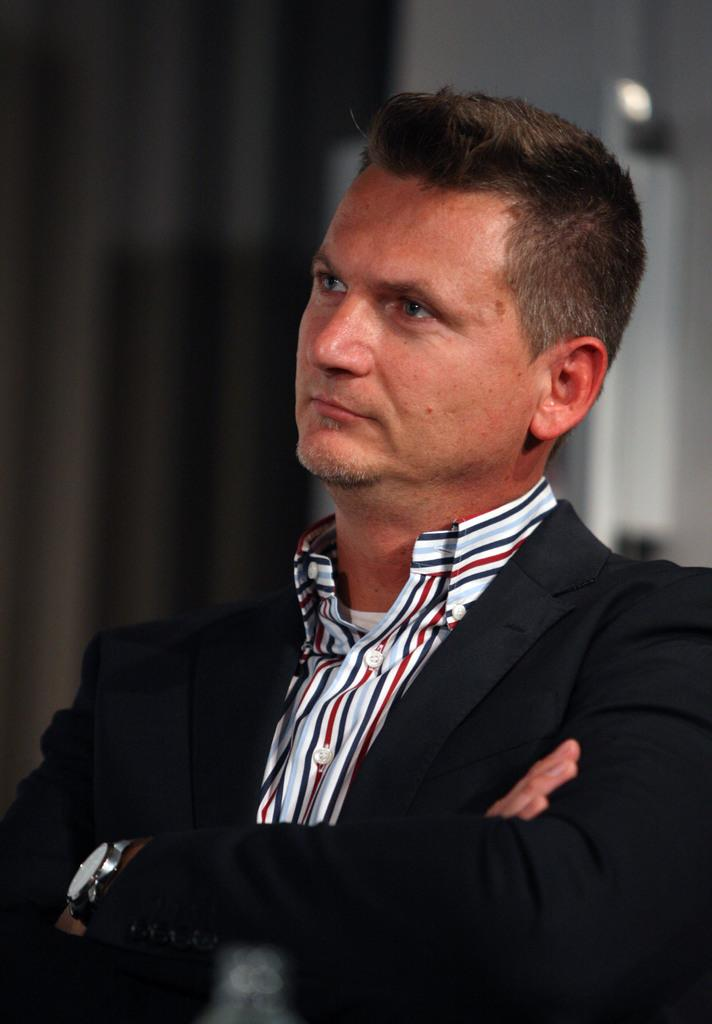What is the person in the image wearing? The person in the image is wearing a suit. In which direction is the person looking? The person is looking towards the left side of the image. Can you describe the background of the image? The background of the image is blurred. What type of pen is the crow holding in the image? There is no crow or pen present in the image. 